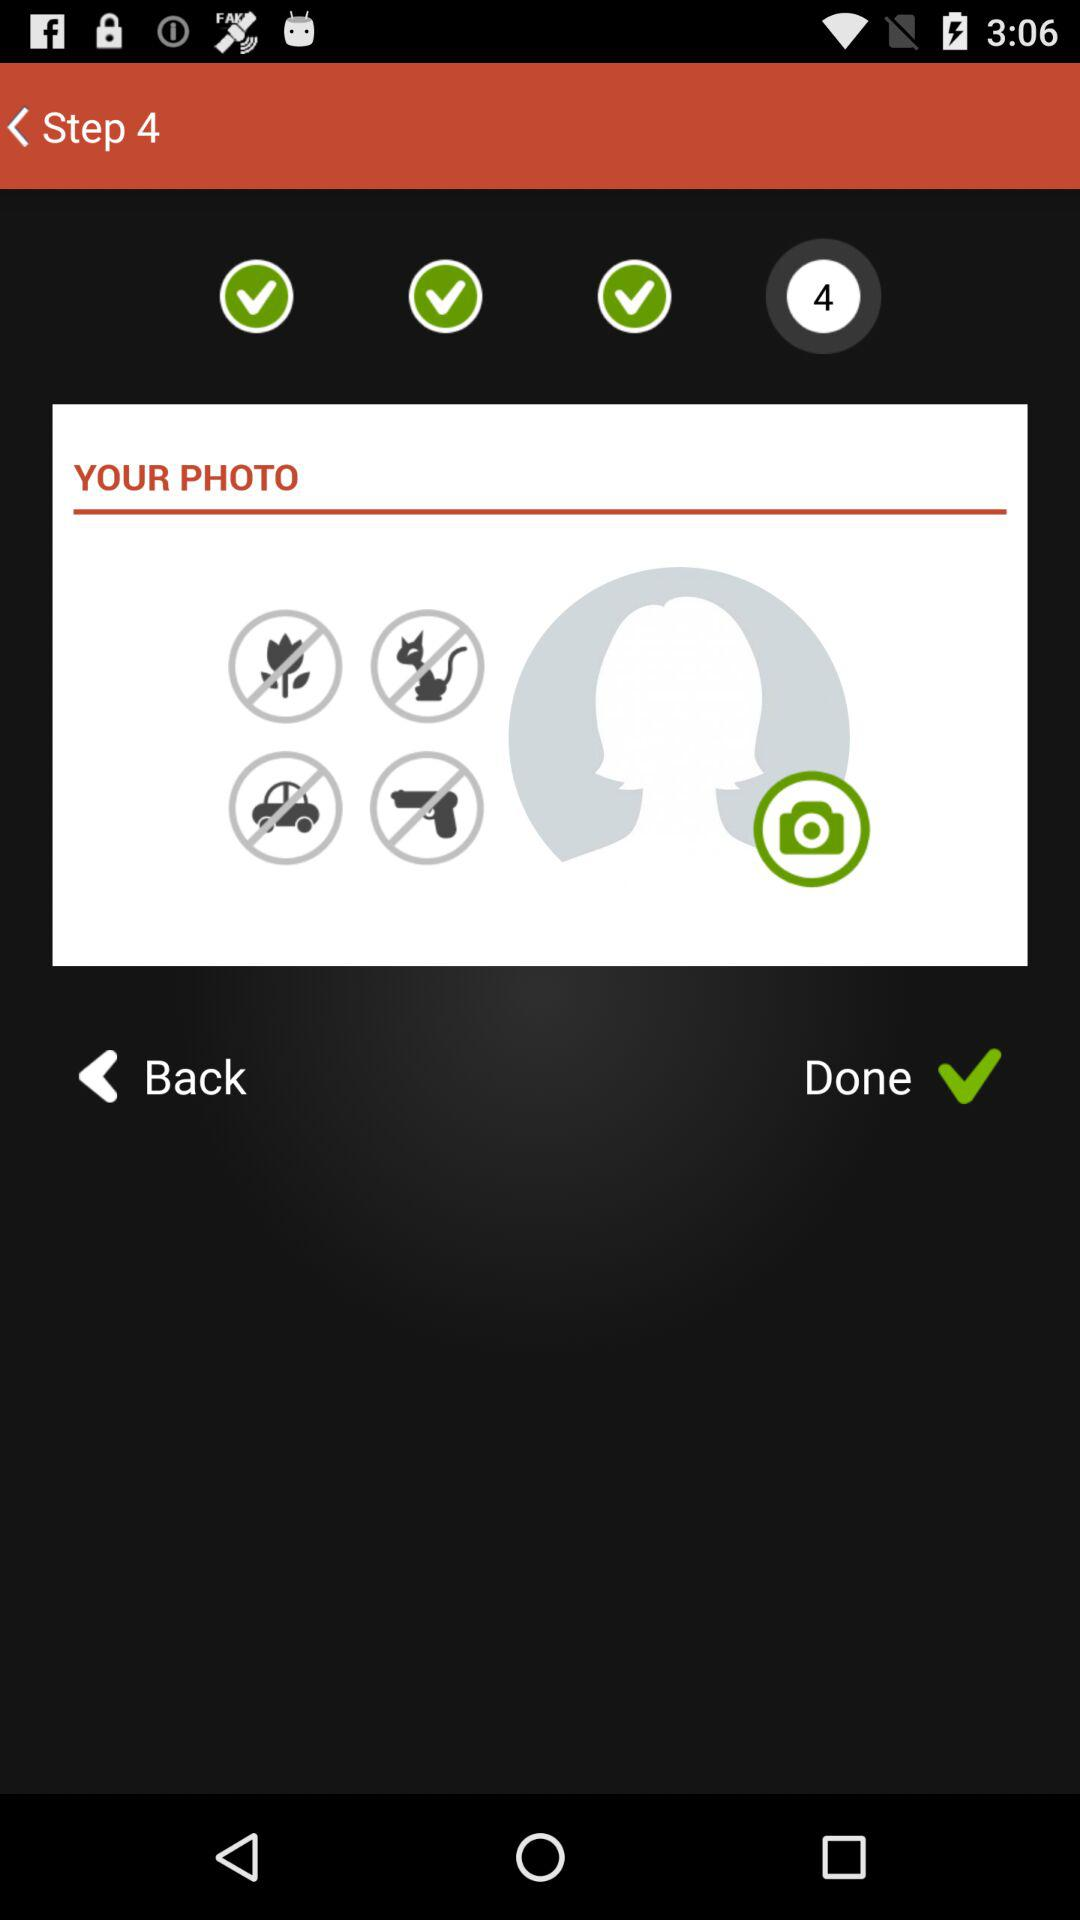How many steps are given? There are 4 steps given. 